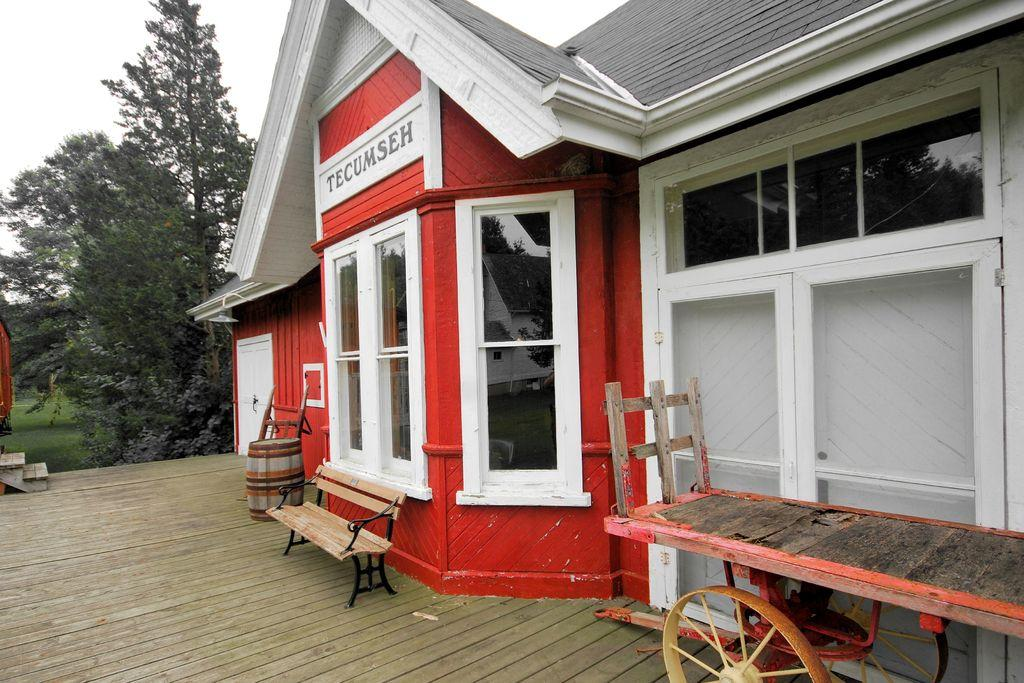What type of structure is visible in the image? There is a house in the image. What can be seen in the background of the image? There are trees and the sky visible in the background of the image. What type of surface is present in the image? There is a floor in the image. What type of seating is present in the image? There is a bench in the image. What type of transportation is present in the image? There is a cart in the image. What type of wine is being served on the bench in the image? There is no wine present in the image; it only features a house, trees, sky, floor, bench, and cart. 